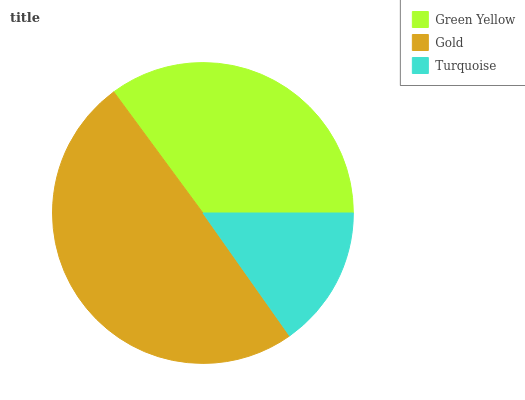Is Turquoise the minimum?
Answer yes or no. Yes. Is Gold the maximum?
Answer yes or no. Yes. Is Gold the minimum?
Answer yes or no. No. Is Turquoise the maximum?
Answer yes or no. No. Is Gold greater than Turquoise?
Answer yes or no. Yes. Is Turquoise less than Gold?
Answer yes or no. Yes. Is Turquoise greater than Gold?
Answer yes or no. No. Is Gold less than Turquoise?
Answer yes or no. No. Is Green Yellow the high median?
Answer yes or no. Yes. Is Green Yellow the low median?
Answer yes or no. Yes. Is Turquoise the high median?
Answer yes or no. No. Is Turquoise the low median?
Answer yes or no. No. 